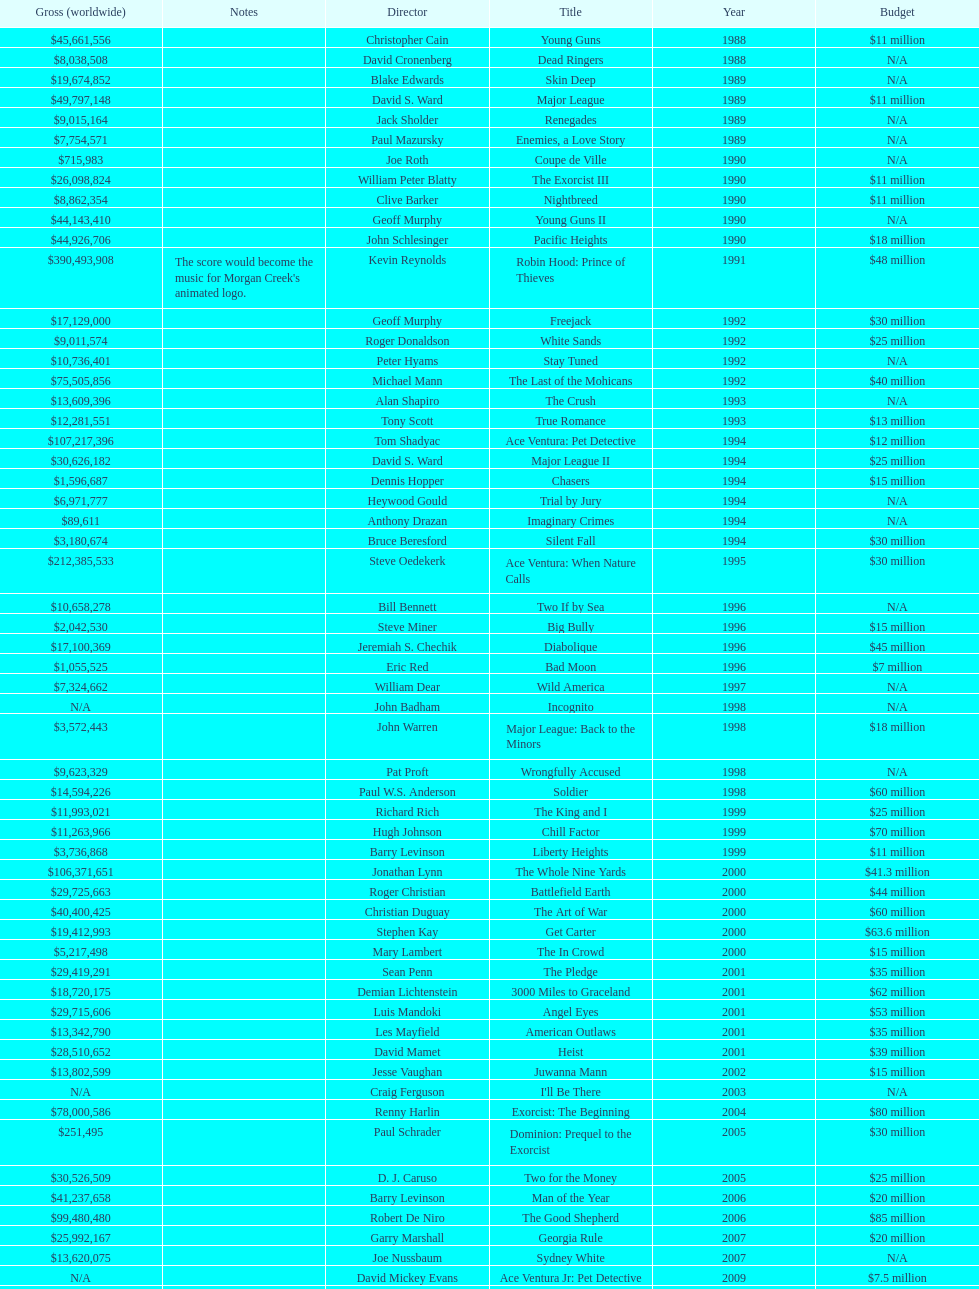Can you give me this table as a dict? {'header': ['Gross (worldwide)', 'Notes', 'Director', 'Title', 'Year', 'Budget'], 'rows': [['$45,661,556', '', 'Christopher Cain', 'Young Guns', '1988', '$11 million'], ['$8,038,508', '', 'David Cronenberg', 'Dead Ringers', '1988', 'N/A'], ['$19,674,852', '', 'Blake Edwards', 'Skin Deep', '1989', 'N/A'], ['$49,797,148', '', 'David S. Ward', 'Major League', '1989', '$11 million'], ['$9,015,164', '', 'Jack Sholder', 'Renegades', '1989', 'N/A'], ['$7,754,571', '', 'Paul Mazursky', 'Enemies, a Love Story', '1989', 'N/A'], ['$715,983', '', 'Joe Roth', 'Coupe de Ville', '1990', 'N/A'], ['$26,098,824', '', 'William Peter Blatty', 'The Exorcist III', '1990', '$11 million'], ['$8,862,354', '', 'Clive Barker', 'Nightbreed', '1990', '$11 million'], ['$44,143,410', '', 'Geoff Murphy', 'Young Guns II', '1990', 'N/A'], ['$44,926,706', '', 'John Schlesinger', 'Pacific Heights', '1990', '$18 million'], ['$390,493,908', "The score would become the music for Morgan Creek's animated logo.", 'Kevin Reynolds', 'Robin Hood: Prince of Thieves', '1991', '$48 million'], ['$17,129,000', '', 'Geoff Murphy', 'Freejack', '1992', '$30 million'], ['$9,011,574', '', 'Roger Donaldson', 'White Sands', '1992', '$25 million'], ['$10,736,401', '', 'Peter Hyams', 'Stay Tuned', '1992', 'N/A'], ['$75,505,856', '', 'Michael Mann', 'The Last of the Mohicans', '1992', '$40 million'], ['$13,609,396', '', 'Alan Shapiro', 'The Crush', '1993', 'N/A'], ['$12,281,551', '', 'Tony Scott', 'True Romance', '1993', '$13 million'], ['$107,217,396', '', 'Tom Shadyac', 'Ace Ventura: Pet Detective', '1994', '$12 million'], ['$30,626,182', '', 'David S. Ward', 'Major League II', '1994', '$25 million'], ['$1,596,687', '', 'Dennis Hopper', 'Chasers', '1994', '$15 million'], ['$6,971,777', '', 'Heywood Gould', 'Trial by Jury', '1994', 'N/A'], ['$89,611', '', 'Anthony Drazan', 'Imaginary Crimes', '1994', 'N/A'], ['$3,180,674', '', 'Bruce Beresford', 'Silent Fall', '1994', '$30 million'], ['$212,385,533', '', 'Steve Oedekerk', 'Ace Ventura: When Nature Calls', '1995', '$30 million'], ['$10,658,278', '', 'Bill Bennett', 'Two If by Sea', '1996', 'N/A'], ['$2,042,530', '', 'Steve Miner', 'Big Bully', '1996', '$15 million'], ['$17,100,369', '', 'Jeremiah S. Chechik', 'Diabolique', '1996', '$45 million'], ['$1,055,525', '', 'Eric Red', 'Bad Moon', '1996', '$7 million'], ['$7,324,662', '', 'William Dear', 'Wild America', '1997', 'N/A'], ['N/A', '', 'John Badham', 'Incognito', '1998', 'N/A'], ['$3,572,443', '', 'John Warren', 'Major League: Back to the Minors', '1998', '$18 million'], ['$9,623,329', '', 'Pat Proft', 'Wrongfully Accused', '1998', 'N/A'], ['$14,594,226', '', 'Paul W.S. Anderson', 'Soldier', '1998', '$60 million'], ['$11,993,021', '', 'Richard Rich', 'The King and I', '1999', '$25 million'], ['$11,263,966', '', 'Hugh Johnson', 'Chill Factor', '1999', '$70 million'], ['$3,736,868', '', 'Barry Levinson', 'Liberty Heights', '1999', '$11 million'], ['$106,371,651', '', 'Jonathan Lynn', 'The Whole Nine Yards', '2000', '$41.3 million'], ['$29,725,663', '', 'Roger Christian', 'Battlefield Earth', '2000', '$44 million'], ['$40,400,425', '', 'Christian Duguay', 'The Art of War', '2000', '$60 million'], ['$19,412,993', '', 'Stephen Kay', 'Get Carter', '2000', '$63.6 million'], ['$5,217,498', '', 'Mary Lambert', 'The In Crowd', '2000', '$15 million'], ['$29,419,291', '', 'Sean Penn', 'The Pledge', '2001', '$35 million'], ['$18,720,175', '', 'Demian Lichtenstein', '3000 Miles to Graceland', '2001', '$62 million'], ['$29,715,606', '', 'Luis Mandoki', 'Angel Eyes', '2001', '$53 million'], ['$13,342,790', '', 'Les Mayfield', 'American Outlaws', '2001', '$35 million'], ['$28,510,652', '', 'David Mamet', 'Heist', '2001', '$39 million'], ['$13,802,599', '', 'Jesse Vaughan', 'Juwanna Mann', '2002', '$15 million'], ['N/A', '', 'Craig Ferguson', "I'll Be There", '2003', 'N/A'], ['$78,000,586', '', 'Renny Harlin', 'Exorcist: The Beginning', '2004', '$80 million'], ['$251,495', '', 'Paul Schrader', 'Dominion: Prequel to the Exorcist', '2005', '$30 million'], ['$30,526,509', '', 'D. J. Caruso', 'Two for the Money', '2005', '$25 million'], ['$41,237,658', '', 'Barry Levinson', 'Man of the Year', '2006', '$20 million'], ['$99,480,480', '', 'Robert De Niro', 'The Good Shepherd', '2006', '$85 million'], ['$25,992,167', '', 'Garry Marshall', 'Georgia Rule', '2007', '$20 million'], ['$13,620,075', '', 'Joe Nussbaum', 'Sydney White', '2007', 'N/A'], ['N/A', '', 'David Mickey Evans', 'Ace Ventura Jr: Pet Detective', '2009', '$7.5 million'], ['$38,502,340', '', 'Jim Sheridan', 'Dream House', '2011', '$50 million'], ['$27,428,670', '', 'Matthijs van Heijningen Jr.', 'The Thing', '2011', '$38 million'], ['', '', 'Antoine Fuqua', 'Tupac', '2014', '$45 million']]} How many films were there in 1990? 5. 